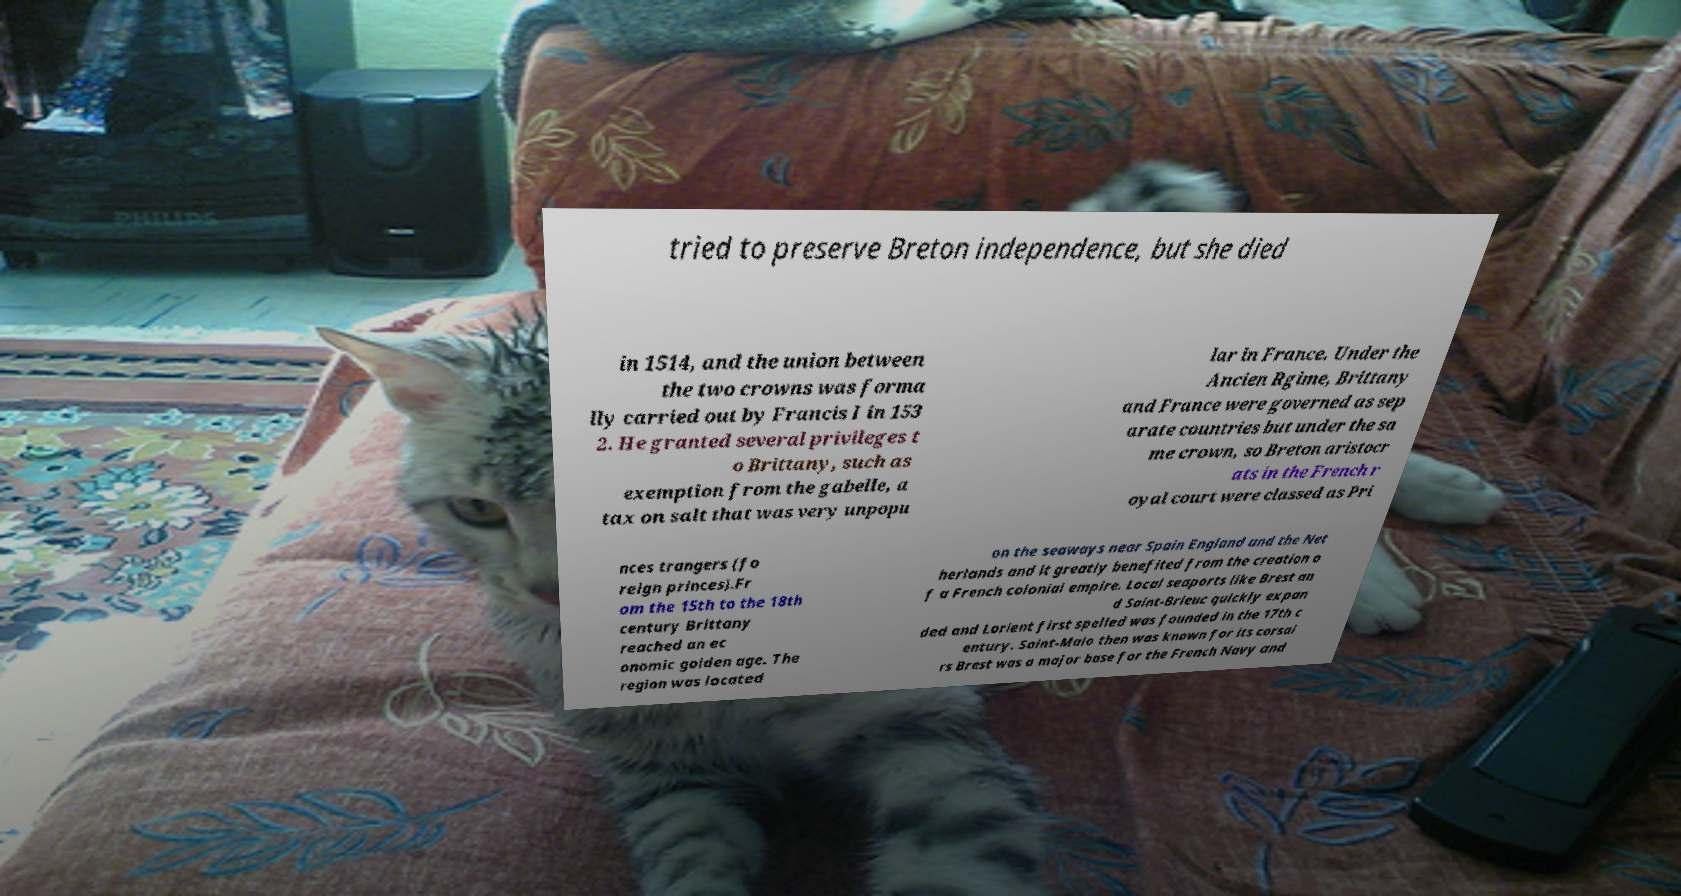For documentation purposes, I need the text within this image transcribed. Could you provide that? tried to preserve Breton independence, but she died in 1514, and the union between the two crowns was forma lly carried out by Francis I in 153 2. He granted several privileges t o Brittany, such as exemption from the gabelle, a tax on salt that was very unpopu lar in France. Under the Ancien Rgime, Brittany and France were governed as sep arate countries but under the sa me crown, so Breton aristocr ats in the French r oyal court were classed as Pri nces trangers (fo reign princes).Fr om the 15th to the 18th century Brittany reached an ec onomic golden age. The region was located on the seaways near Spain England and the Net herlands and it greatly benefited from the creation o f a French colonial empire. Local seaports like Brest an d Saint-Brieuc quickly expan ded and Lorient first spelled was founded in the 17th c entury. Saint-Malo then was known for its corsai rs Brest was a major base for the French Navy and 